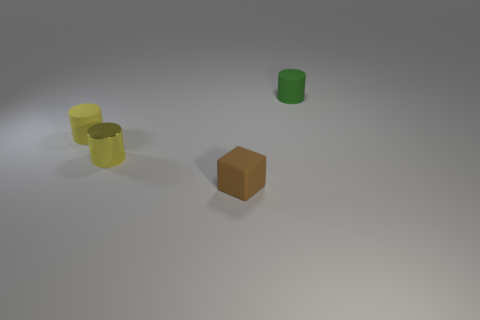Do the small green thing and the metal thing have the same shape? No, they do not. The small green object appears to be cylindrical, while the metal-looking object is cubic. 